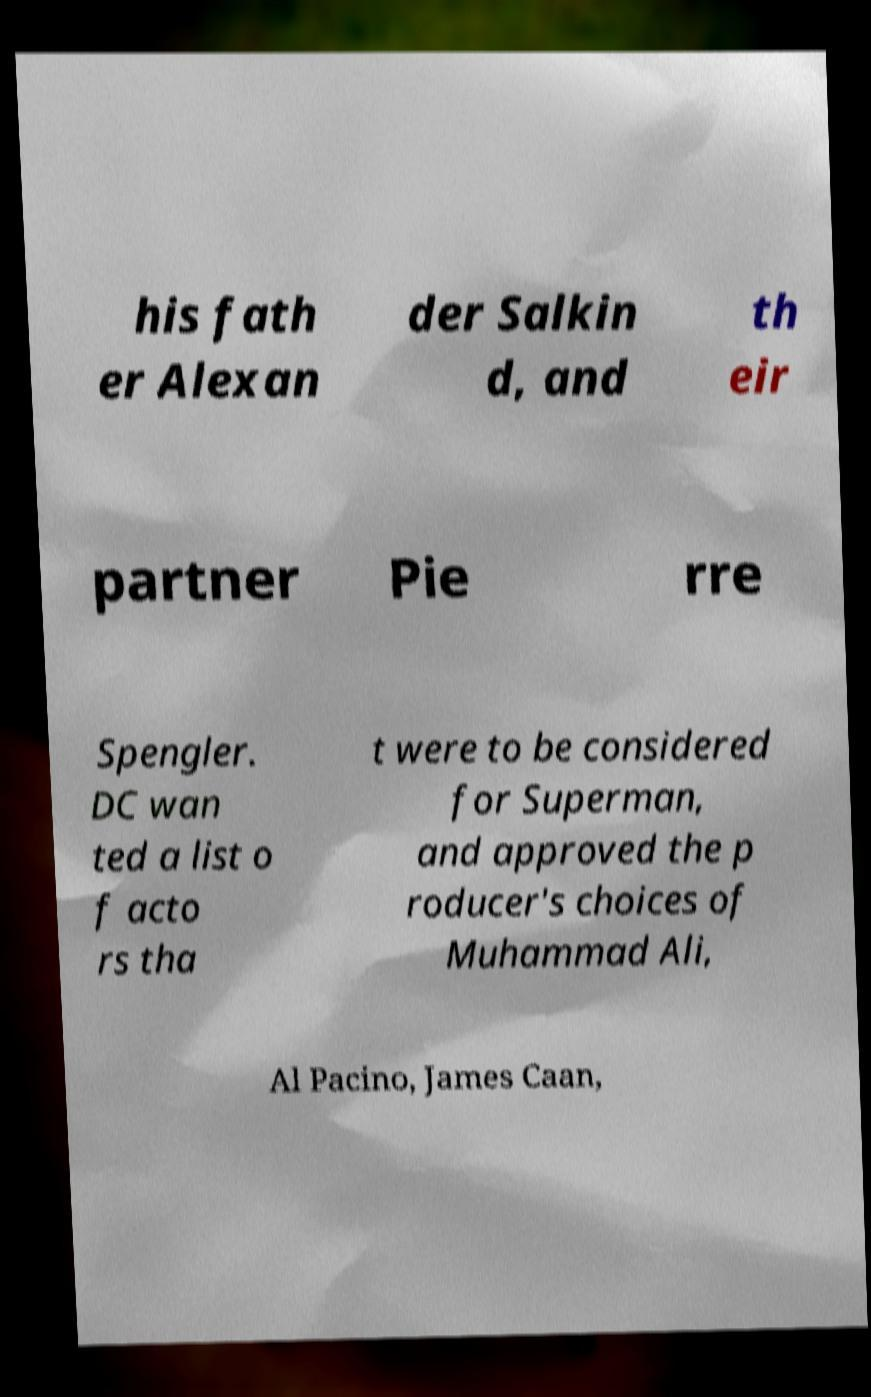Can you read and provide the text displayed in the image?This photo seems to have some interesting text. Can you extract and type it out for me? his fath er Alexan der Salkin d, and th eir partner Pie rre Spengler. DC wan ted a list o f acto rs tha t were to be considered for Superman, and approved the p roducer's choices of Muhammad Ali, Al Pacino, James Caan, 